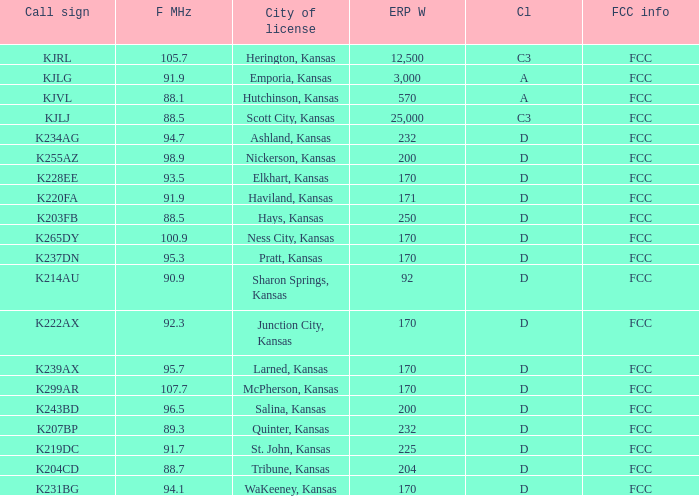Frequency MHz smaller than 95.3, and a Call sign of k234ag is what class? D. 